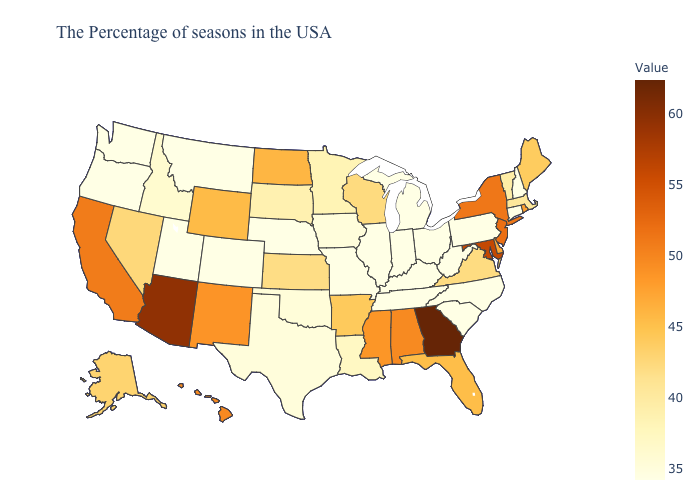Among the states that border Delaware , does Maryland have the lowest value?
Concise answer only. No. 